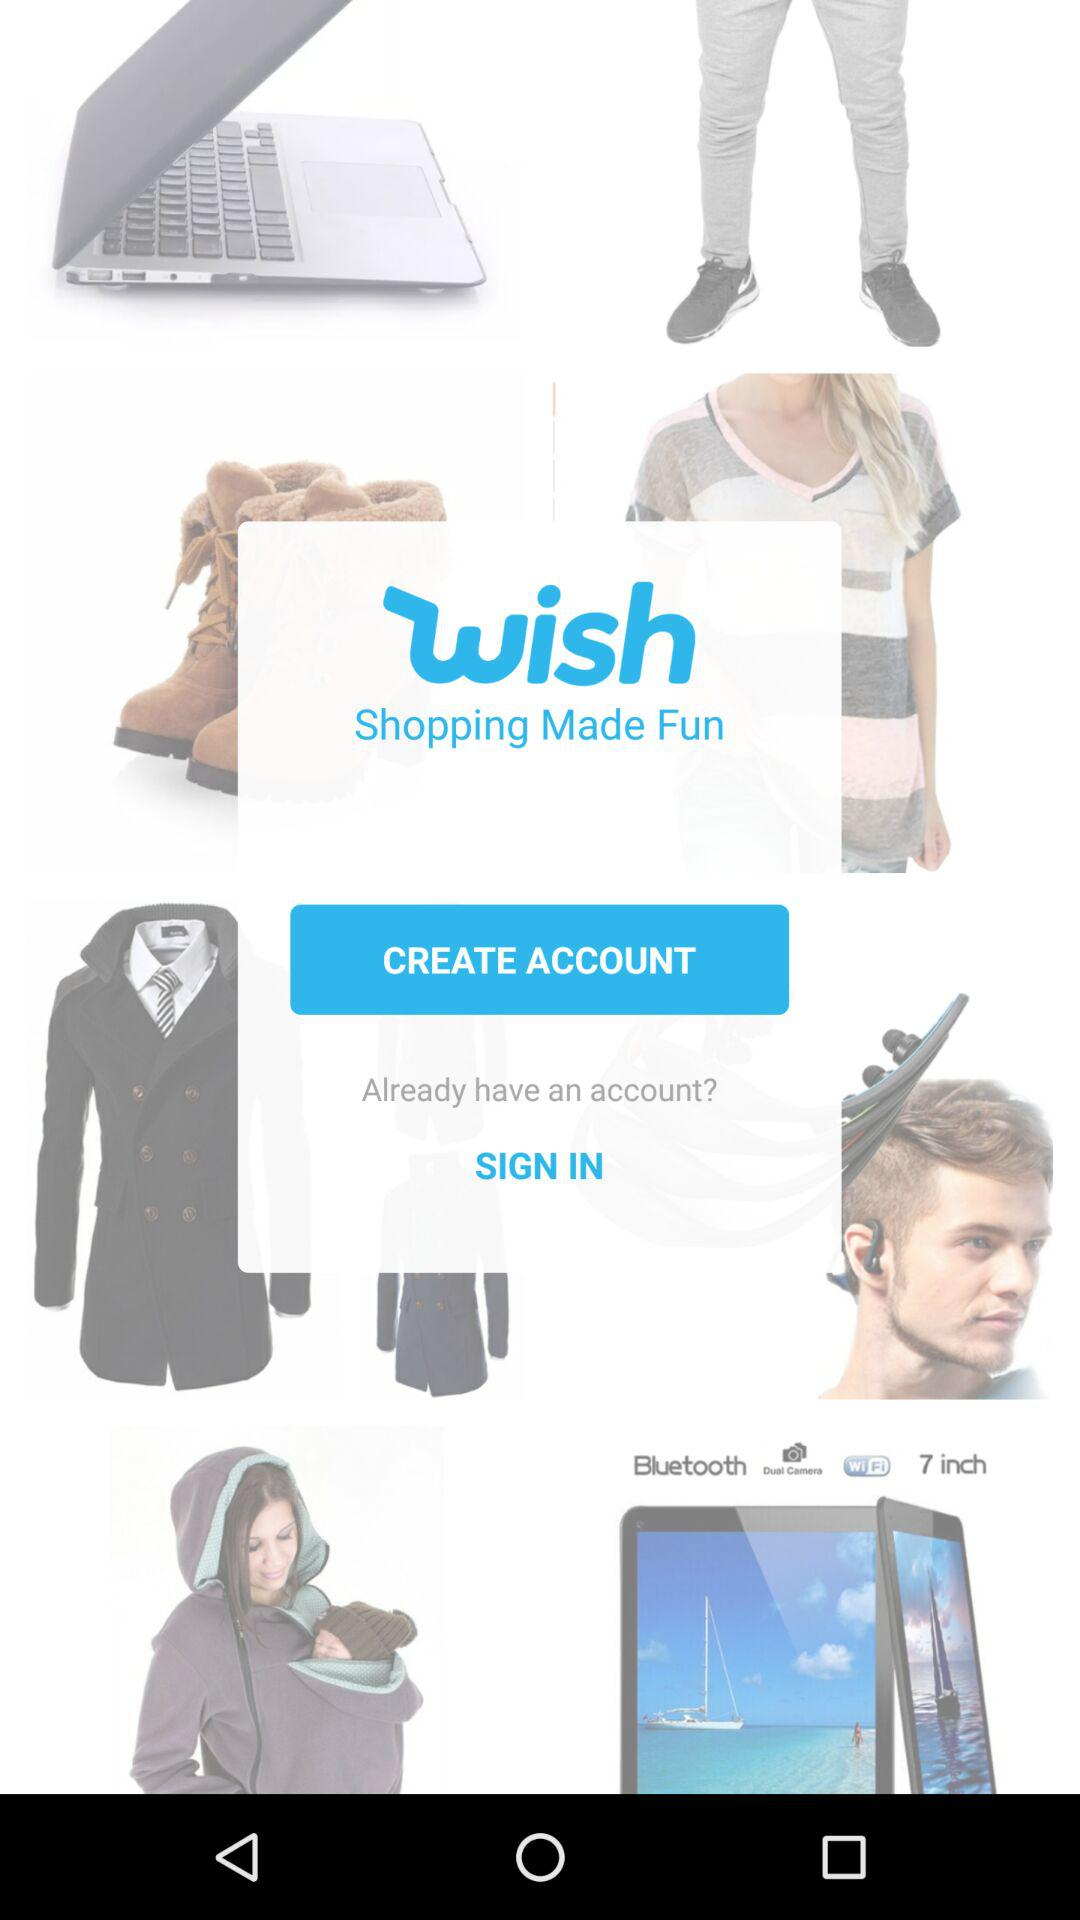What is the name of the application? The name of the application is "Wish Shopping Made Fun". 